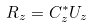<formula> <loc_0><loc_0><loc_500><loc_500>R _ { z } = C _ { z } ^ { * } U _ { z }</formula> 